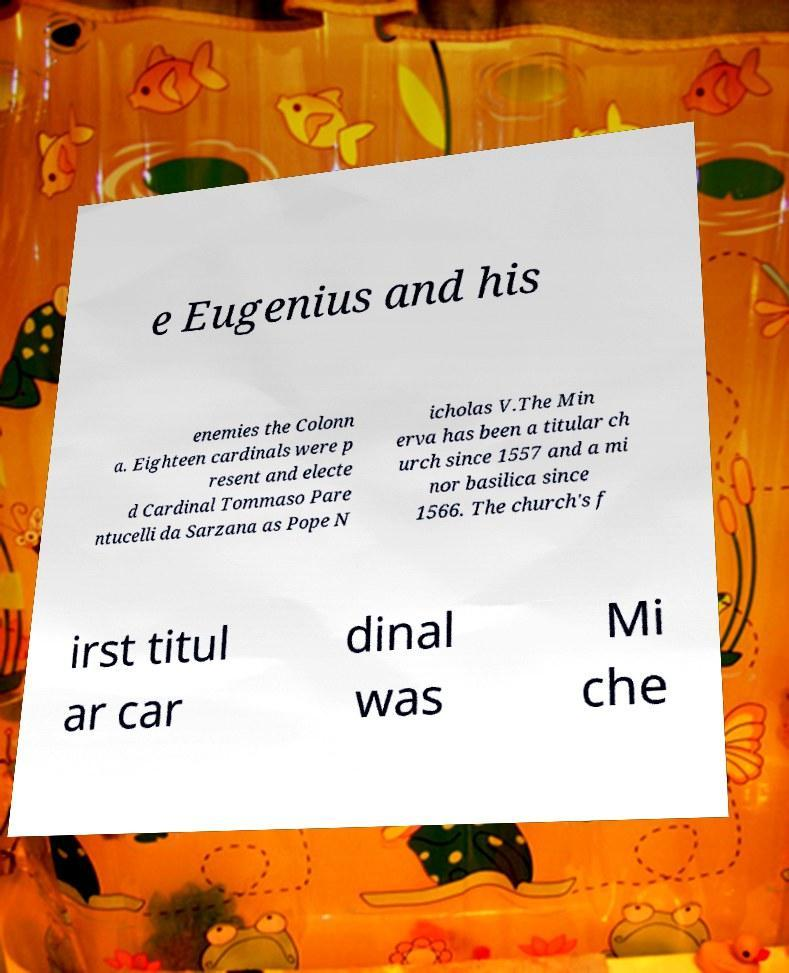For documentation purposes, I need the text within this image transcribed. Could you provide that? e Eugenius and his enemies the Colonn a. Eighteen cardinals were p resent and electe d Cardinal Tommaso Pare ntucelli da Sarzana as Pope N icholas V.The Min erva has been a titular ch urch since 1557 and a mi nor basilica since 1566. The church's f irst titul ar car dinal was Mi che 